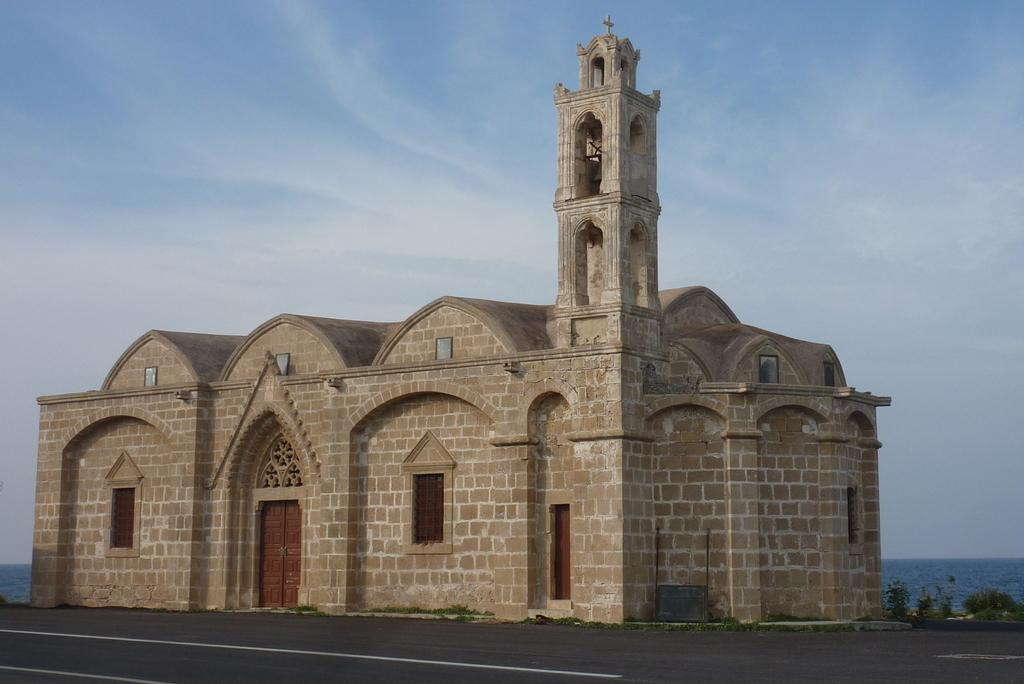What type of structure is present in the image? There is a building in the image. What feature of the building is mentioned in the facts? The building has a door. What is located at the bottom of the image? There is a road at the bottom of the image. What can be seen at the top of the image? The sky is visible at the top of the image. What type of stitch is used to sew the building in the image? There is no stitching involved in the image, as it is a photograph of a real building. 